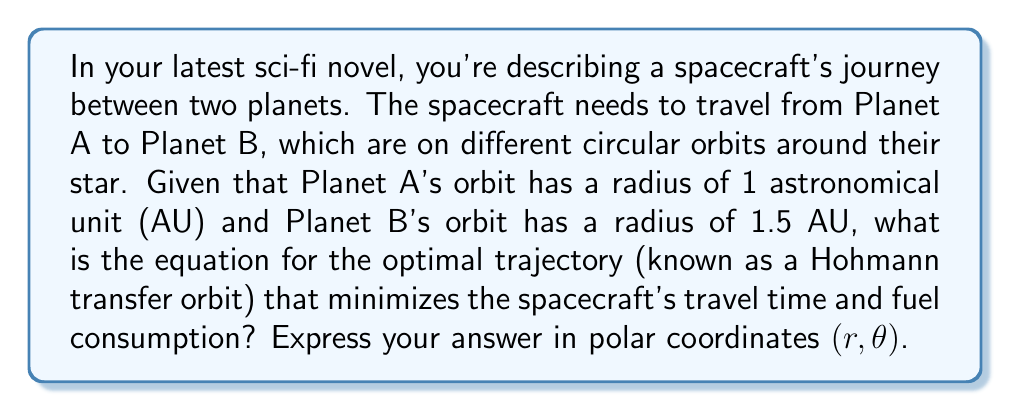What is the answer to this math problem? To solve this problem, we'll use concepts from orbital mechanics and the properties of elliptical orbits:

1. A Hohmann transfer orbit is an elliptical orbit that touches both the origin and destination orbits tangentially.

2. The semi-major axis (a) of the transfer orbit is the average of the two orbital radii:

   $$a = \frac{r_1 + r_2}{2} = \frac{1 + 1.5}{2} = 1.25 \text{ AU}$$

3. The eccentricity (e) of the transfer orbit can be calculated using:

   $$e = \frac{r_2 - r_1}{r_2 + r_1} = \frac{1.5 - 1}{1.5 + 1} = 0.2$$

4. The general equation for an ellipse in polar coordinates is:

   $$r = \frac{a(1-e^2)}{1 + e\cos\theta}$$

5. Substituting our values for a and e:

   $$r = \frac{1.25(1-0.2^2)}{1 + 0.2\cos\theta}$$

6. Simplifying:

   $$r = \frac{1.25(0.96)}{1 + 0.2\cos\theta} = \frac{1.2}{1 + 0.2\cos\theta}$$

This equation describes the optimal Hohmann transfer orbit for the spacecraft's journey.
Answer: $$r = \frac{1.2}{1 + 0.2\cos\theta}$$ 